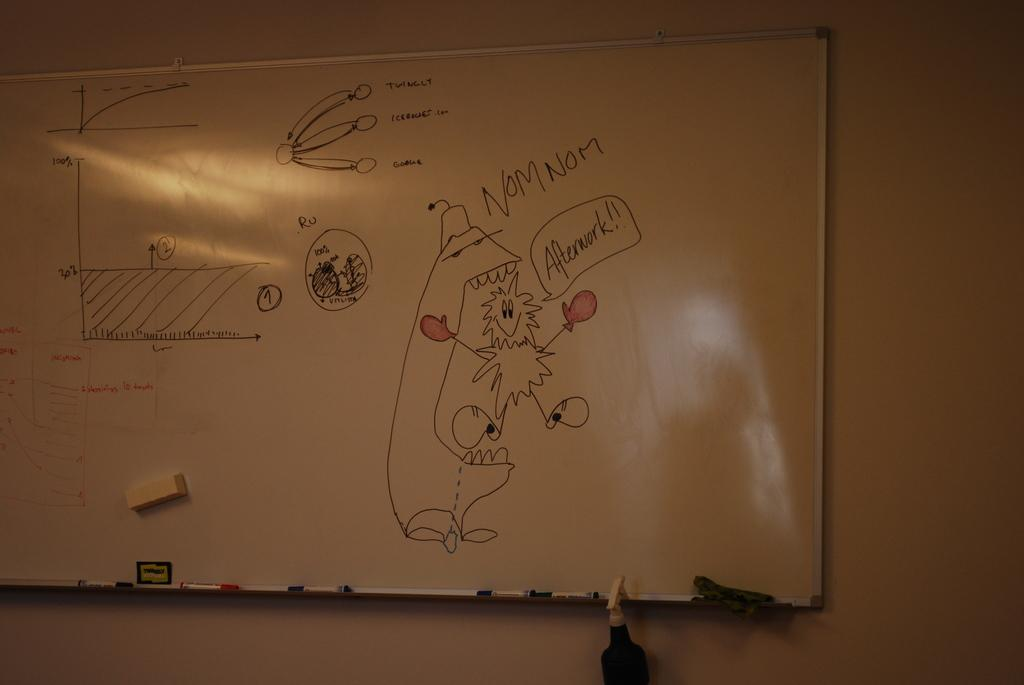Provide a one-sentence caption for the provided image. A dry erase board has a graph and a picture of a happy, fuzzy being saying, "Afterwork!" and labeled with the saying, "NOM NOM.". 